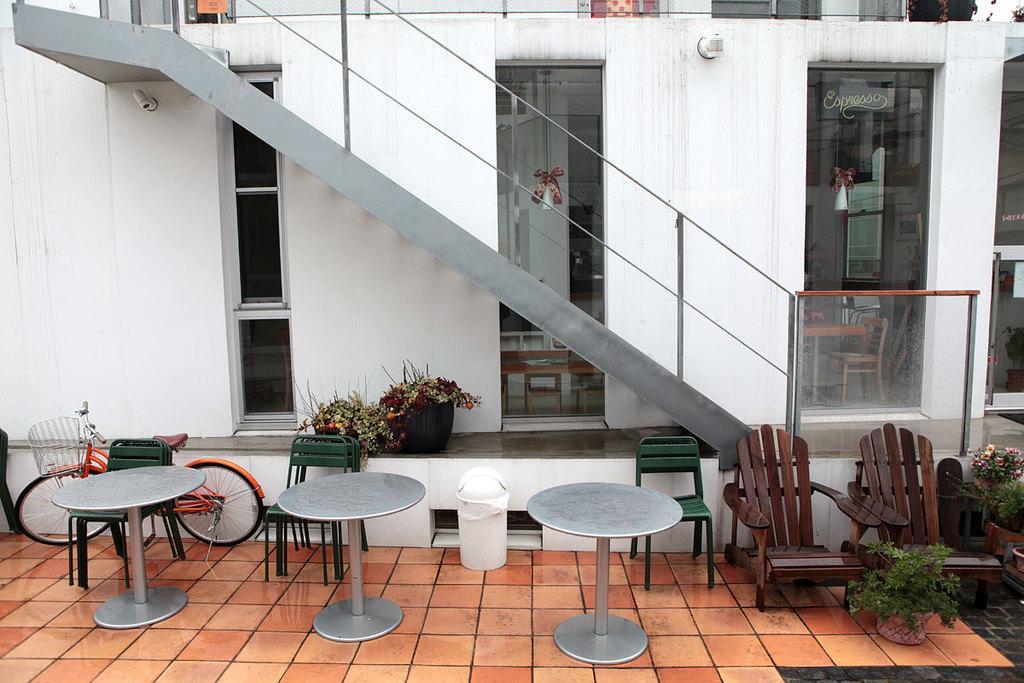Could you give a brief overview of what you see in this image? In this picture there are chairs and circular tables at the bottom side of the image and there are plant pots in the image and there is a staircase and glass windows in the image. 